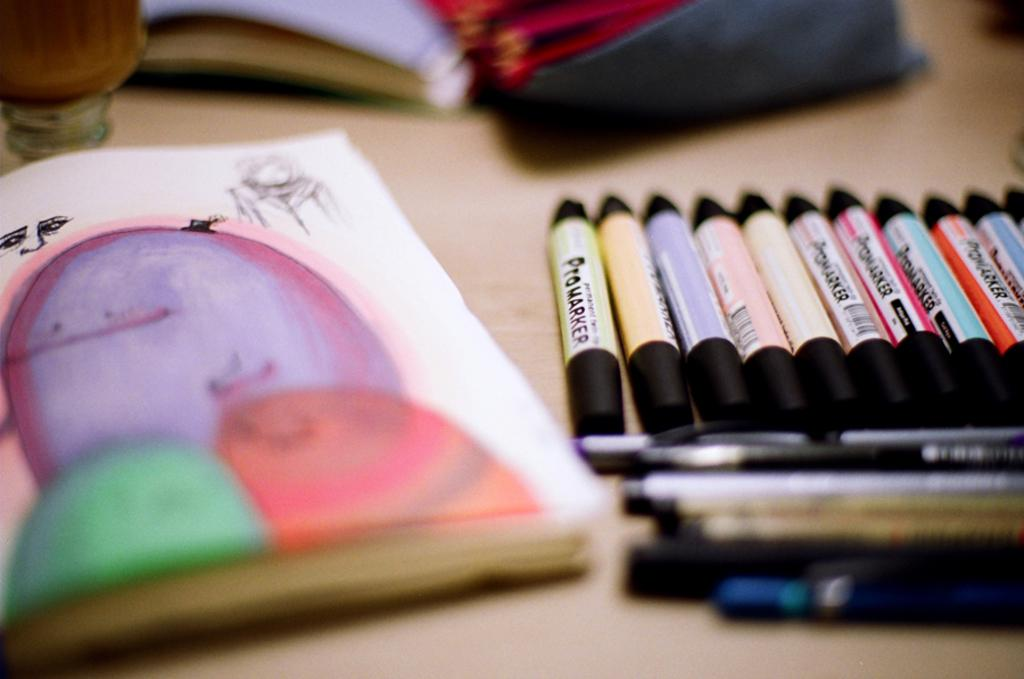<image>
Relay a brief, clear account of the picture shown. A coloring book is on a table next to Pro marker color markers. 